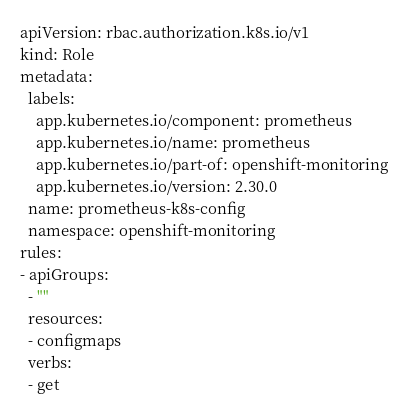<code> <loc_0><loc_0><loc_500><loc_500><_YAML_>apiVersion: rbac.authorization.k8s.io/v1
kind: Role
metadata:
  labels:
    app.kubernetes.io/component: prometheus
    app.kubernetes.io/name: prometheus
    app.kubernetes.io/part-of: openshift-monitoring
    app.kubernetes.io/version: 2.30.0
  name: prometheus-k8s-config
  namespace: openshift-monitoring
rules:
- apiGroups:
  - ""
  resources:
  - configmaps
  verbs:
  - get
</code> 